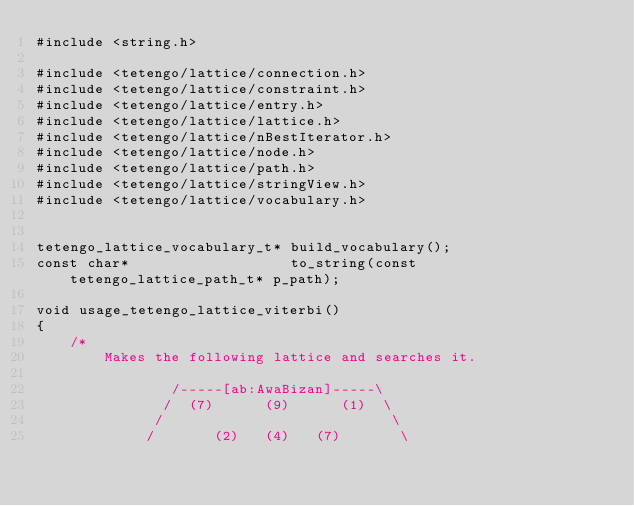<code> <loc_0><loc_0><loc_500><loc_500><_C_>#include <string.h>

#include <tetengo/lattice/connection.h>
#include <tetengo/lattice/constraint.h>
#include <tetengo/lattice/entry.h>
#include <tetengo/lattice/lattice.h>
#include <tetengo/lattice/nBestIterator.h>
#include <tetengo/lattice/node.h>
#include <tetengo/lattice/path.h>
#include <tetengo/lattice/stringView.h>
#include <tetengo/lattice/vocabulary.h>


tetengo_lattice_vocabulary_t* build_vocabulary();
const char*                   to_string(const tetengo_lattice_path_t* p_path);

void usage_tetengo_lattice_viterbi()
{
    /*
        Makes the following lattice and searches it.

                /-----[ab:AwaBizan]-----\
               /  (7)      (9)      (1)  \
              /                           \
             /       (2)   (4)   (7)       \</code> 